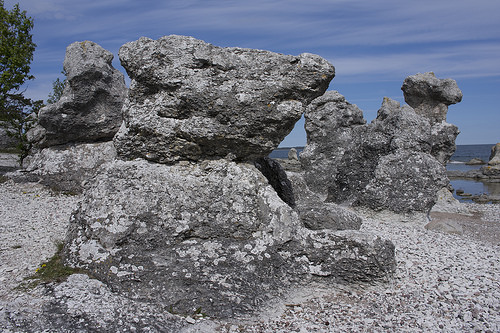<image>
Is there a rock behind the rock? No. The rock is not behind the rock. From this viewpoint, the rock appears to be positioned elsewhere in the scene. 